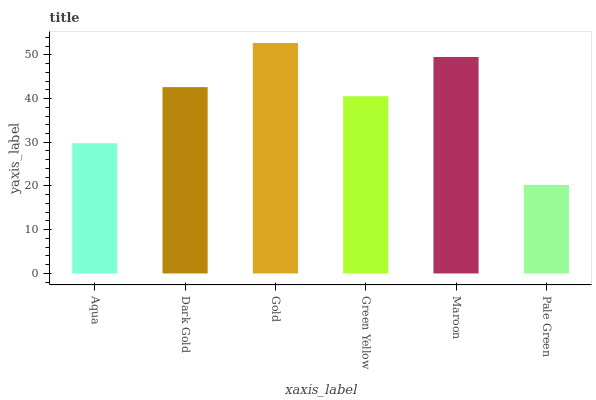Is Dark Gold the minimum?
Answer yes or no. No. Is Dark Gold the maximum?
Answer yes or no. No. Is Dark Gold greater than Aqua?
Answer yes or no. Yes. Is Aqua less than Dark Gold?
Answer yes or no. Yes. Is Aqua greater than Dark Gold?
Answer yes or no. No. Is Dark Gold less than Aqua?
Answer yes or no. No. Is Dark Gold the high median?
Answer yes or no. Yes. Is Green Yellow the low median?
Answer yes or no. Yes. Is Pale Green the high median?
Answer yes or no. No. Is Maroon the low median?
Answer yes or no. No. 